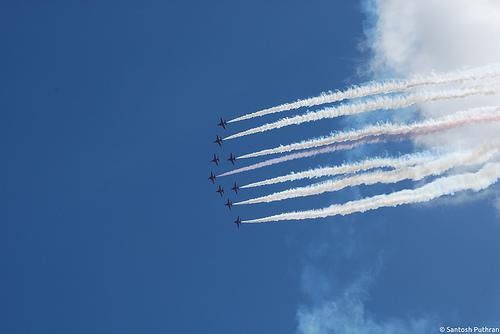Question: why is there trails of smoke in the sky?
Choices:
A. From the train.
B. From airplanes.
C. From the chimney.
D. From the building.
Answer with the letter. Answer: B Question: how many airplanes are there?
Choices:
A. Nine.
B. Ten.
C. Five.
D. Six.
Answer with the letter. Answer: A Question: what are the planes doing?
Choices:
A. Flying.
B. Parking.
C. Landing.
D. Departing.
Answer with the letter. Answer: A Question: when is this picture taken?
Choices:
A. Morning.
B. Night.
C. During the day.
D. Afternoon.
Answer with the letter. Answer: C 